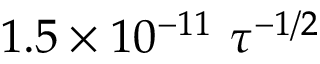<formula> <loc_0><loc_0><loc_500><loc_500>1 . 5 \times 1 0 ^ { - 1 1 } \tau ^ { - 1 / 2 }</formula> 